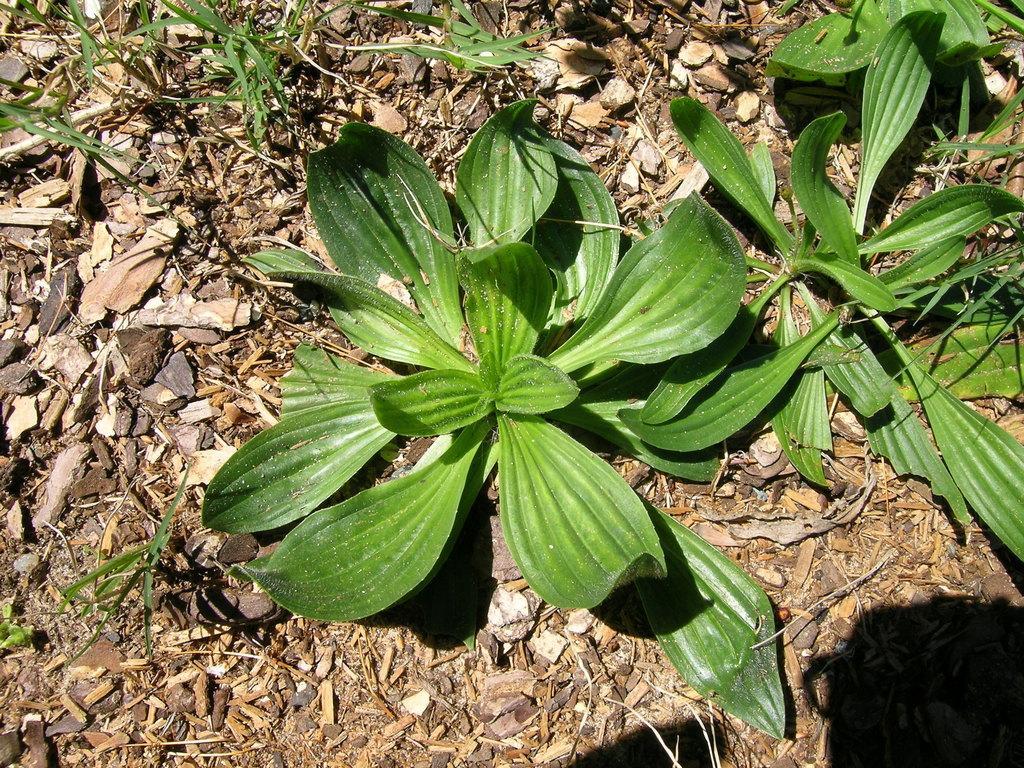Can you describe this image briefly? In this image there are plants and leaves on the surface, on the surface there are dry leaves, branches and stones. 